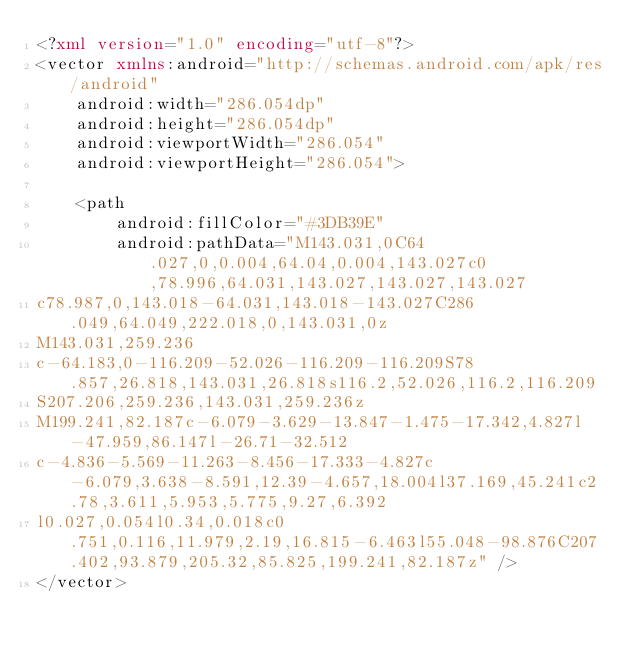Convert code to text. <code><loc_0><loc_0><loc_500><loc_500><_XML_><?xml version="1.0" encoding="utf-8"?>
<vector xmlns:android="http://schemas.android.com/apk/res/android"
    android:width="286.054dp"
    android:height="286.054dp"
    android:viewportWidth="286.054"
    android:viewportHeight="286.054">

    <path
        android:fillColor="#3DB39E"
        android:pathData="M143.031,0C64.027,0,0.004,64.04,0.004,143.027c0,78.996,64.031,143.027,143.027,143.027
c78.987,0,143.018-64.031,143.018-143.027C286.049,64.049,222.018,0,143.031,0z
M143.031,259.236
c-64.183,0-116.209-52.026-116.209-116.209S78.857,26.818,143.031,26.818s116.2,52.026,116.2,116.209
S207.206,259.236,143.031,259.236z
M199.241,82.187c-6.079-3.629-13.847-1.475-17.342,4.827l-47.959,86.147l-26.71-32.512
c-4.836-5.569-11.263-8.456-17.333-4.827c-6.079,3.638-8.591,12.39-4.657,18.004l37.169,45.241c2.78,3.611,5.953,5.775,9.27,6.392
l0.027,0.054l0.34,0.018c0.751,0.116,11.979,2.19,16.815-6.463l55.048-98.876C207.402,93.879,205.32,85.825,199.241,82.187z" />
</vector></code> 